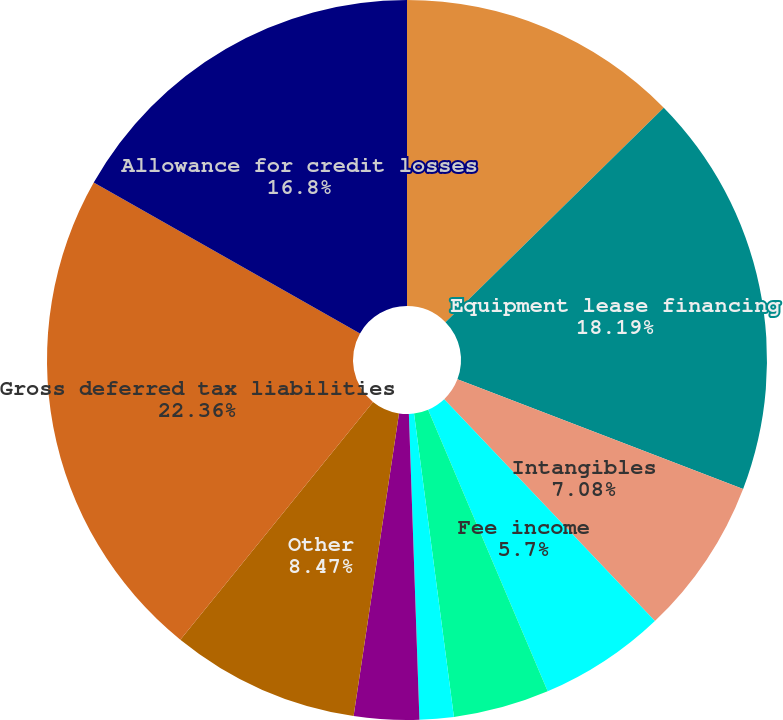Convert chart to OTSL. <chart><loc_0><loc_0><loc_500><loc_500><pie_chart><fcel>(Dollars in millions)<fcel>Equipment lease financing<fcel>Intangibles<fcel>Fee income<fcel>Mortgage servicing rights<fcel>State income taxes<fcel>Foreign currency<fcel>Other<fcel>Gross deferred tax liabilities<fcel>Allowance for credit losses<nl><fcel>12.64%<fcel>18.19%<fcel>7.08%<fcel>5.7%<fcel>4.31%<fcel>1.53%<fcel>2.92%<fcel>8.47%<fcel>22.36%<fcel>16.8%<nl></chart> 